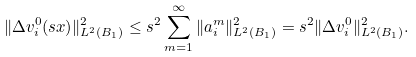Convert formula to latex. <formula><loc_0><loc_0><loc_500><loc_500>\| \Delta v ^ { 0 } _ { i } ( s x ) \| ^ { 2 } _ { L ^ { 2 } ( B _ { 1 } ) } \leq s ^ { 2 } \sum _ { m = 1 } ^ { \infty } \| a ^ { m } _ { i } \| ^ { 2 } _ { L ^ { 2 } ( B _ { 1 } ) } = s ^ { 2 } \| \Delta v ^ { 0 } _ { i } \| ^ { 2 } _ { L ^ { 2 } ( B _ { 1 } ) } .</formula> 